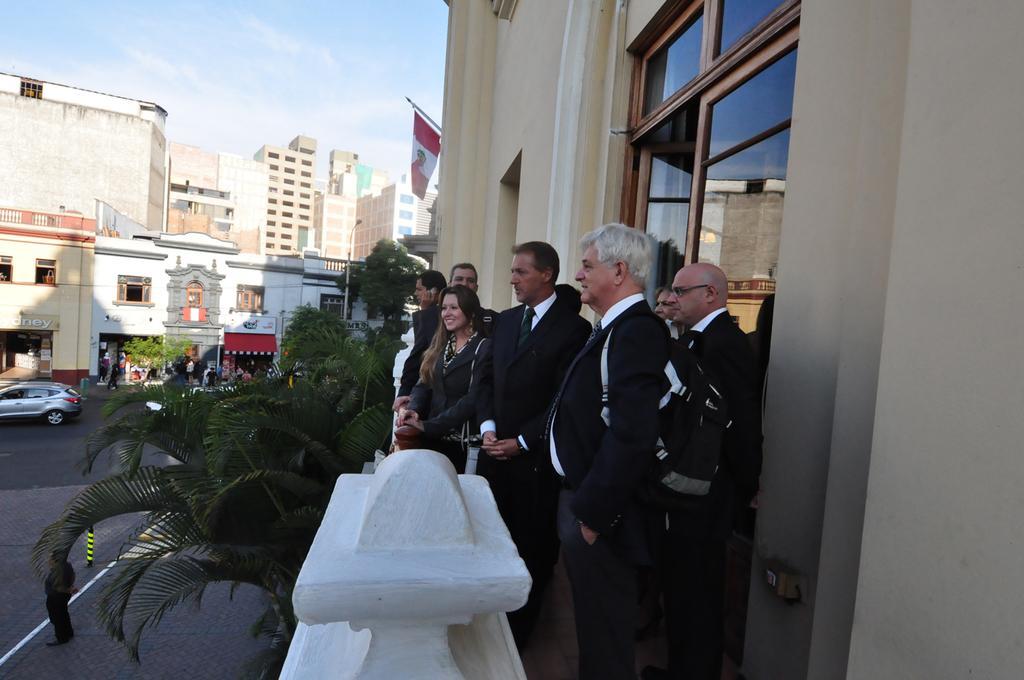Please provide a concise description of this image. There are few persons. Here we can see plants, poles, boards, flag, and buildings. There is a car on the road. In the background we can see sky. 